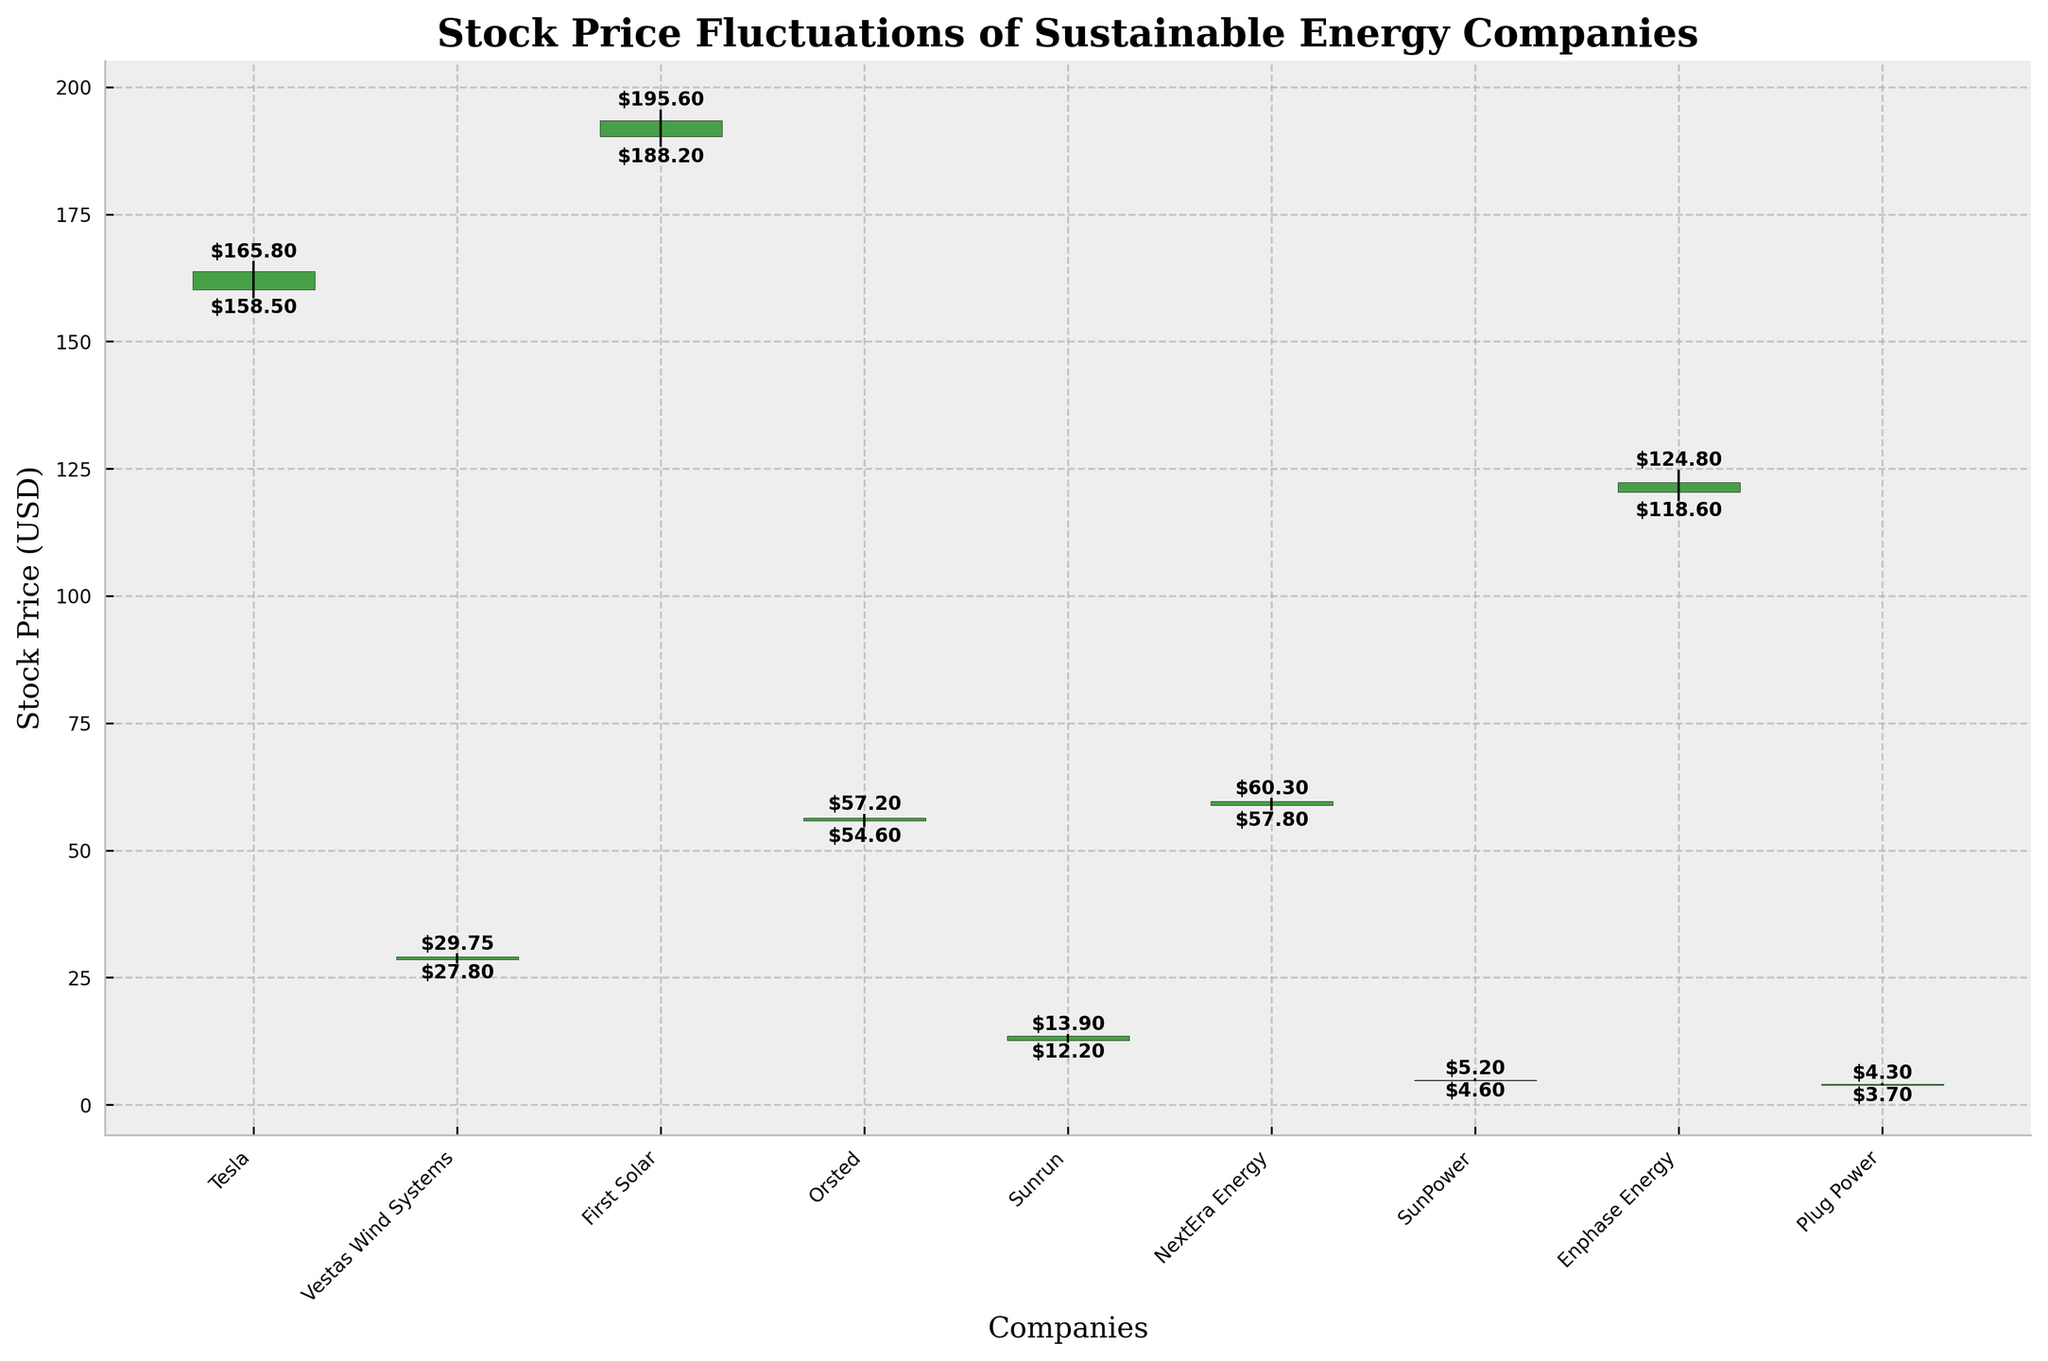What is the highest stock price of Tesla during the recorded period? The highest stock price for Tesla can be found by looking at the data point labeled "Tesla" on the x-axis and referring to the highest price marked on the y-axis. In this case, the highest price is indicated as $165.80.
Answer: $165.80 Which company had the lowest closing price, and what was it? The lowest closing price can be determined by comparing the closing prices of all companies. The company "SunPower" has the lowest closing price, which is $4.90.
Answer: SunPower, $4.90 How much did the stock price of Enphase Energy increase from open to close? For Enphase Energy, subtract the opening price from the closing price. The open price was $120.40, and the close price was $122.30. The increase is $122.30 - $120.40 = $1.90.
Answer: $1.90 Which company experienced the largest range in stock price on its given date, and what was the range? The range of each company's stock price is the difference between the highest and lowest price. First Solar has the largest range, with a high of $195.60 and a low of $188.20. The range is $195.60 - $188.20 = $7.40.
Answer: First Solar, $7.40 Did any company's stock price decrease from open to close? To determine this, check if the closing price is lower than the opening price for each company. SunPower is one such company, with an open price of $4.80 and a closing price of $4.90.
Answer: No Comparing Tesla and Orsted, which had a higher opening price on their given dates? Compare the opening prices of the two companies: Tesla's opening price is $160.20 and Orsted's opening price is $55.80. Tesla's opening price is higher.
Answer: Tesla What was the price range for Sunrun? The range is determined by subtracting the lowest price from the highest price. For Sunrun, the high was $13.90, and the low was $12.20. The range is $13.90 - $12.20 = $1.70.
Answer: $1.70 Which company had the smallest difference between its open and close prices? Calculate the difference between open and close prices for each company and find the smallest. For "Plug Power," the difference is $4.10 - $3.90 = $0.20, which is the smallest among all.
Answer: Plug Power 